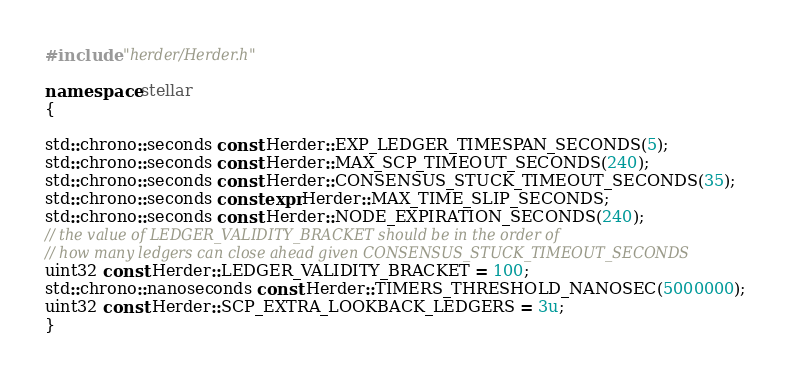Convert code to text. <code><loc_0><loc_0><loc_500><loc_500><_C++_>
#include "herder/Herder.h"

namespace stellar
{

std::chrono::seconds const Herder::EXP_LEDGER_TIMESPAN_SECONDS(5);
std::chrono::seconds const Herder::MAX_SCP_TIMEOUT_SECONDS(240);
std::chrono::seconds const Herder::CONSENSUS_STUCK_TIMEOUT_SECONDS(35);
std::chrono::seconds constexpr Herder::MAX_TIME_SLIP_SECONDS;
std::chrono::seconds const Herder::NODE_EXPIRATION_SECONDS(240);
// the value of LEDGER_VALIDITY_BRACKET should be in the order of
// how many ledgers can close ahead given CONSENSUS_STUCK_TIMEOUT_SECONDS
uint32 const Herder::LEDGER_VALIDITY_BRACKET = 100;
std::chrono::nanoseconds const Herder::TIMERS_THRESHOLD_NANOSEC(5000000);
uint32 const Herder::SCP_EXTRA_LOOKBACK_LEDGERS = 3u;
}
</code> 